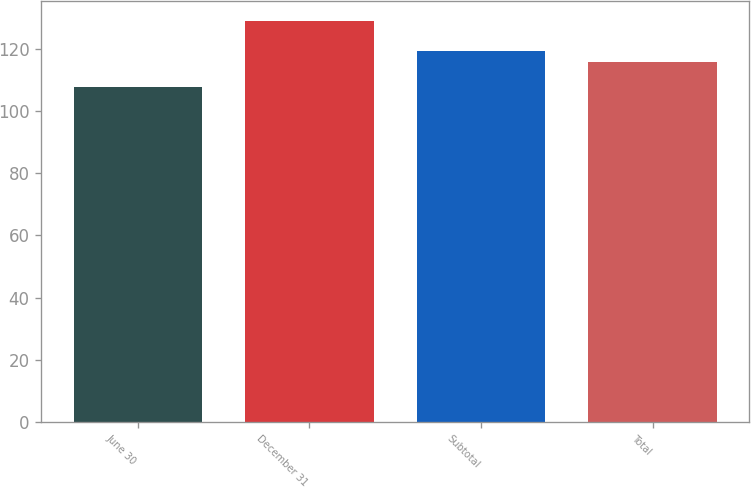Convert chart to OTSL. <chart><loc_0><loc_0><loc_500><loc_500><bar_chart><fcel>June 30<fcel>December 31<fcel>Subtotal<fcel>Total<nl><fcel>107.74<fcel>129.18<fcel>119.54<fcel>115.85<nl></chart> 